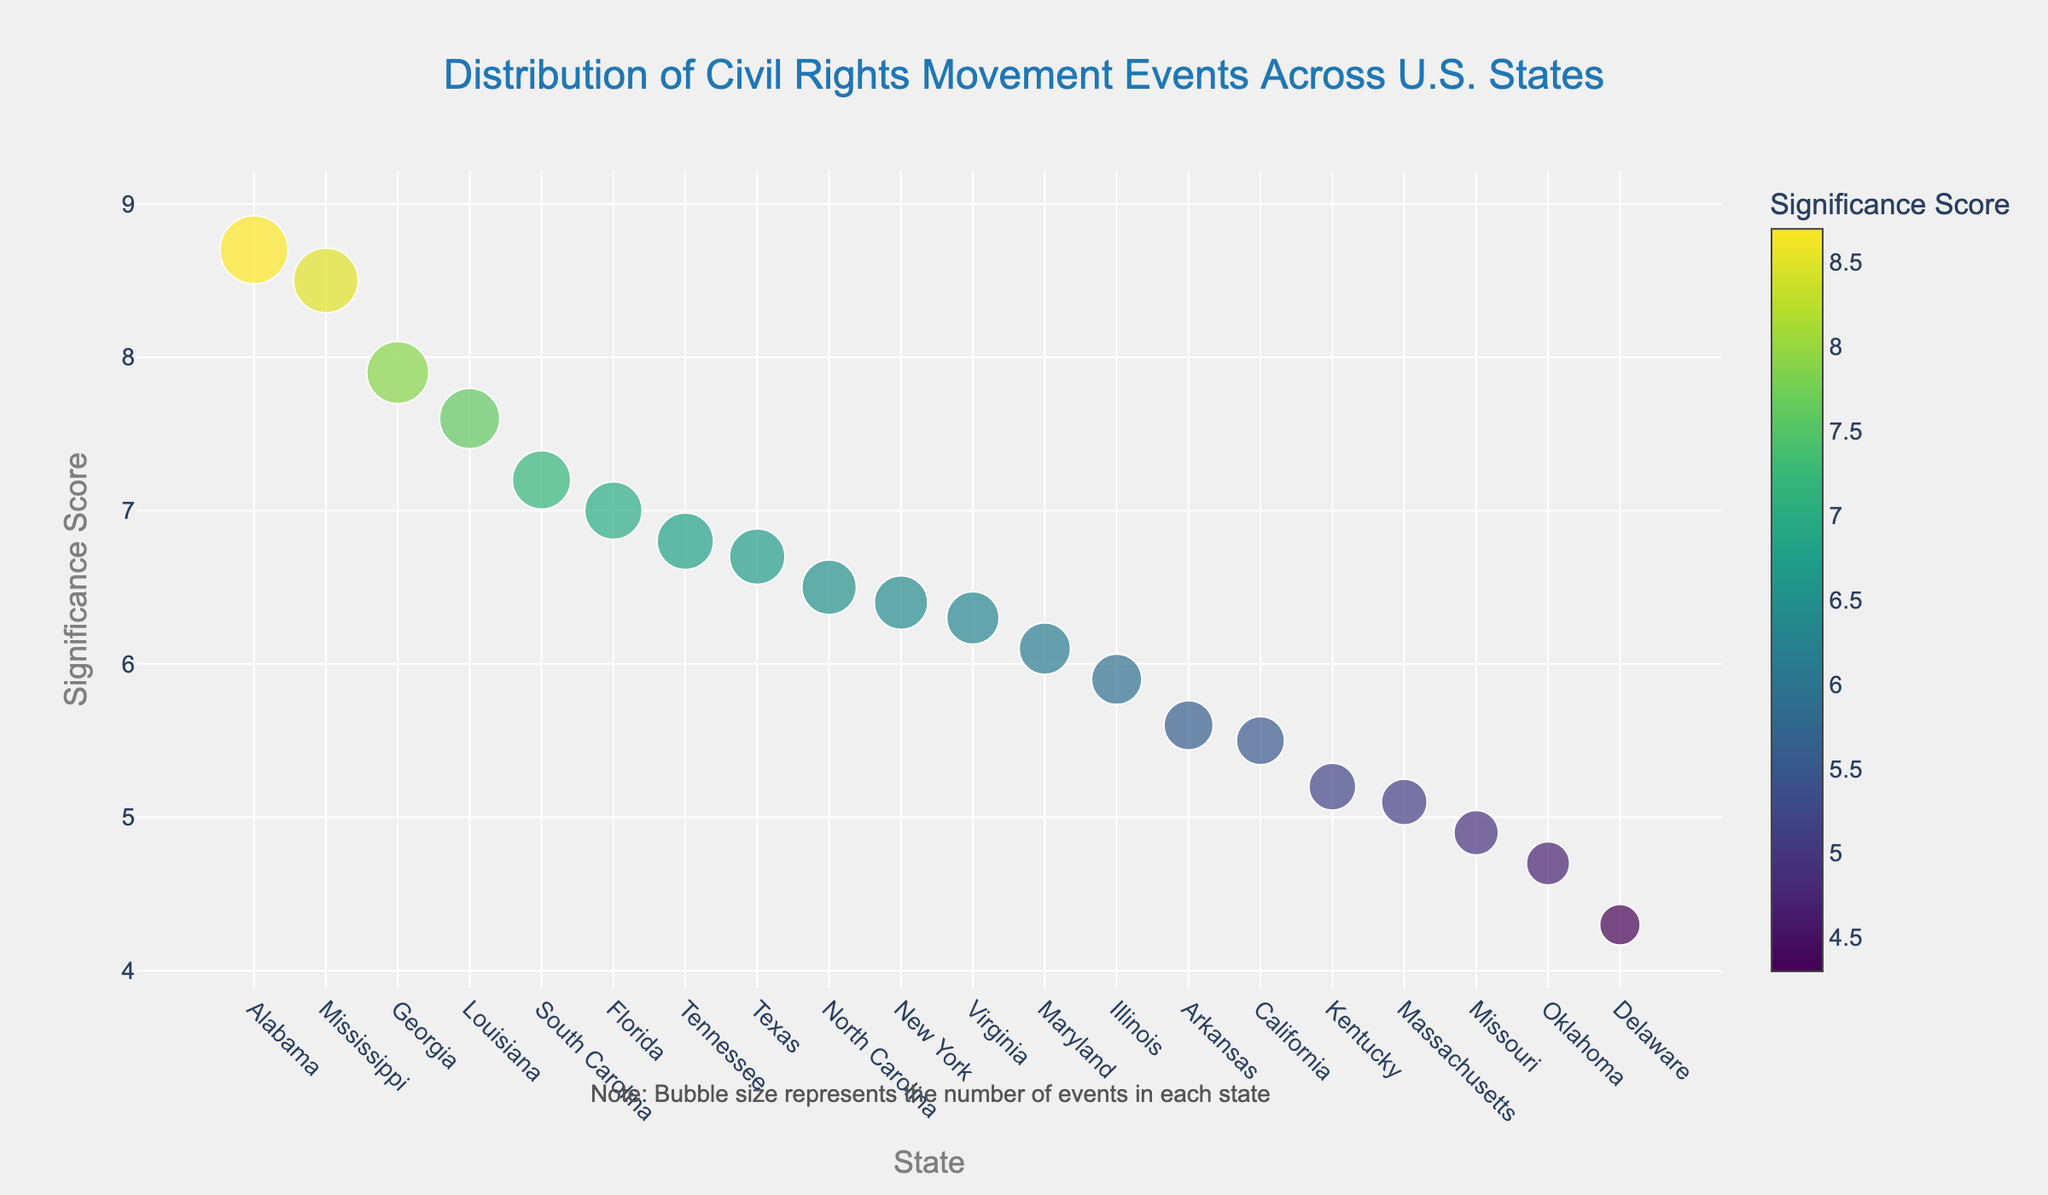What is the significance score for Alabama? Look at the y-axis value associated with the state marker labeled "Alabama" on the x-axis. The significance score is 8.7.
Answer: 8.7 Which state has the highest significance score? Observe the y-axis and identify the state with the highest significance score marker. The state with the highest significance score is Alabama.
Answer: Alabama How many events occurred in Mississippi? Refer to the tooltip or hover over the marker representing Mississippi. The number of events in Mississippi is 38.
Answer: 38 Compare the significance score of Georgia and Tennessee. Which state has a higher score? Find the markers for Georgia and Tennessee on the x-axis. Compare their y-axis values. Georgia has a significance score of 7.9 while Tennessee has a significance score of 6.8. Therefore, Georgia has a higher score.
Answer: Georgia Which state has more events, New York or Illinois? Hover over the markers for New York and Illinois to see their event counts. New York has 26 events while Illinois has 23 events. Thus, New York has more events.
Answer: New York By how much does Alabama's significance score differ from that of Florida? Determine the significance scores of Alabama and Florida, which are 8.7 and 7.0 respectively. Subtract Florida's score from Alabama's score: 8.7 - 7.0 = 1.7
Answer: 1.7 Count the number of states with a significance score of 6.5 or higher. Identify the states with significance scores of 6.5 or higher (Alabama, Georgia, Mississippi, South Carolina, Florida, Louisiana, and New York). There are 7 states.
Answer: 7 Which state has the lowest number of events, and what is its significance score? Locate the marker with the smallest size to determine the state with the lowest number of events (Delaware with 15 events). Its significance score is 4.3.
Answer: Delaware, 4.3 Do Texas and North Carolina have the same significance score, and if so, what is it? Check the markers for Texas and North Carolina to compare their y-axis values. Texas has a significance score of 6.7 and North Carolina has a score of 6.5. They do not have the same score.
Answer: No, Texas: 6.7, North Carolina: 6.5 